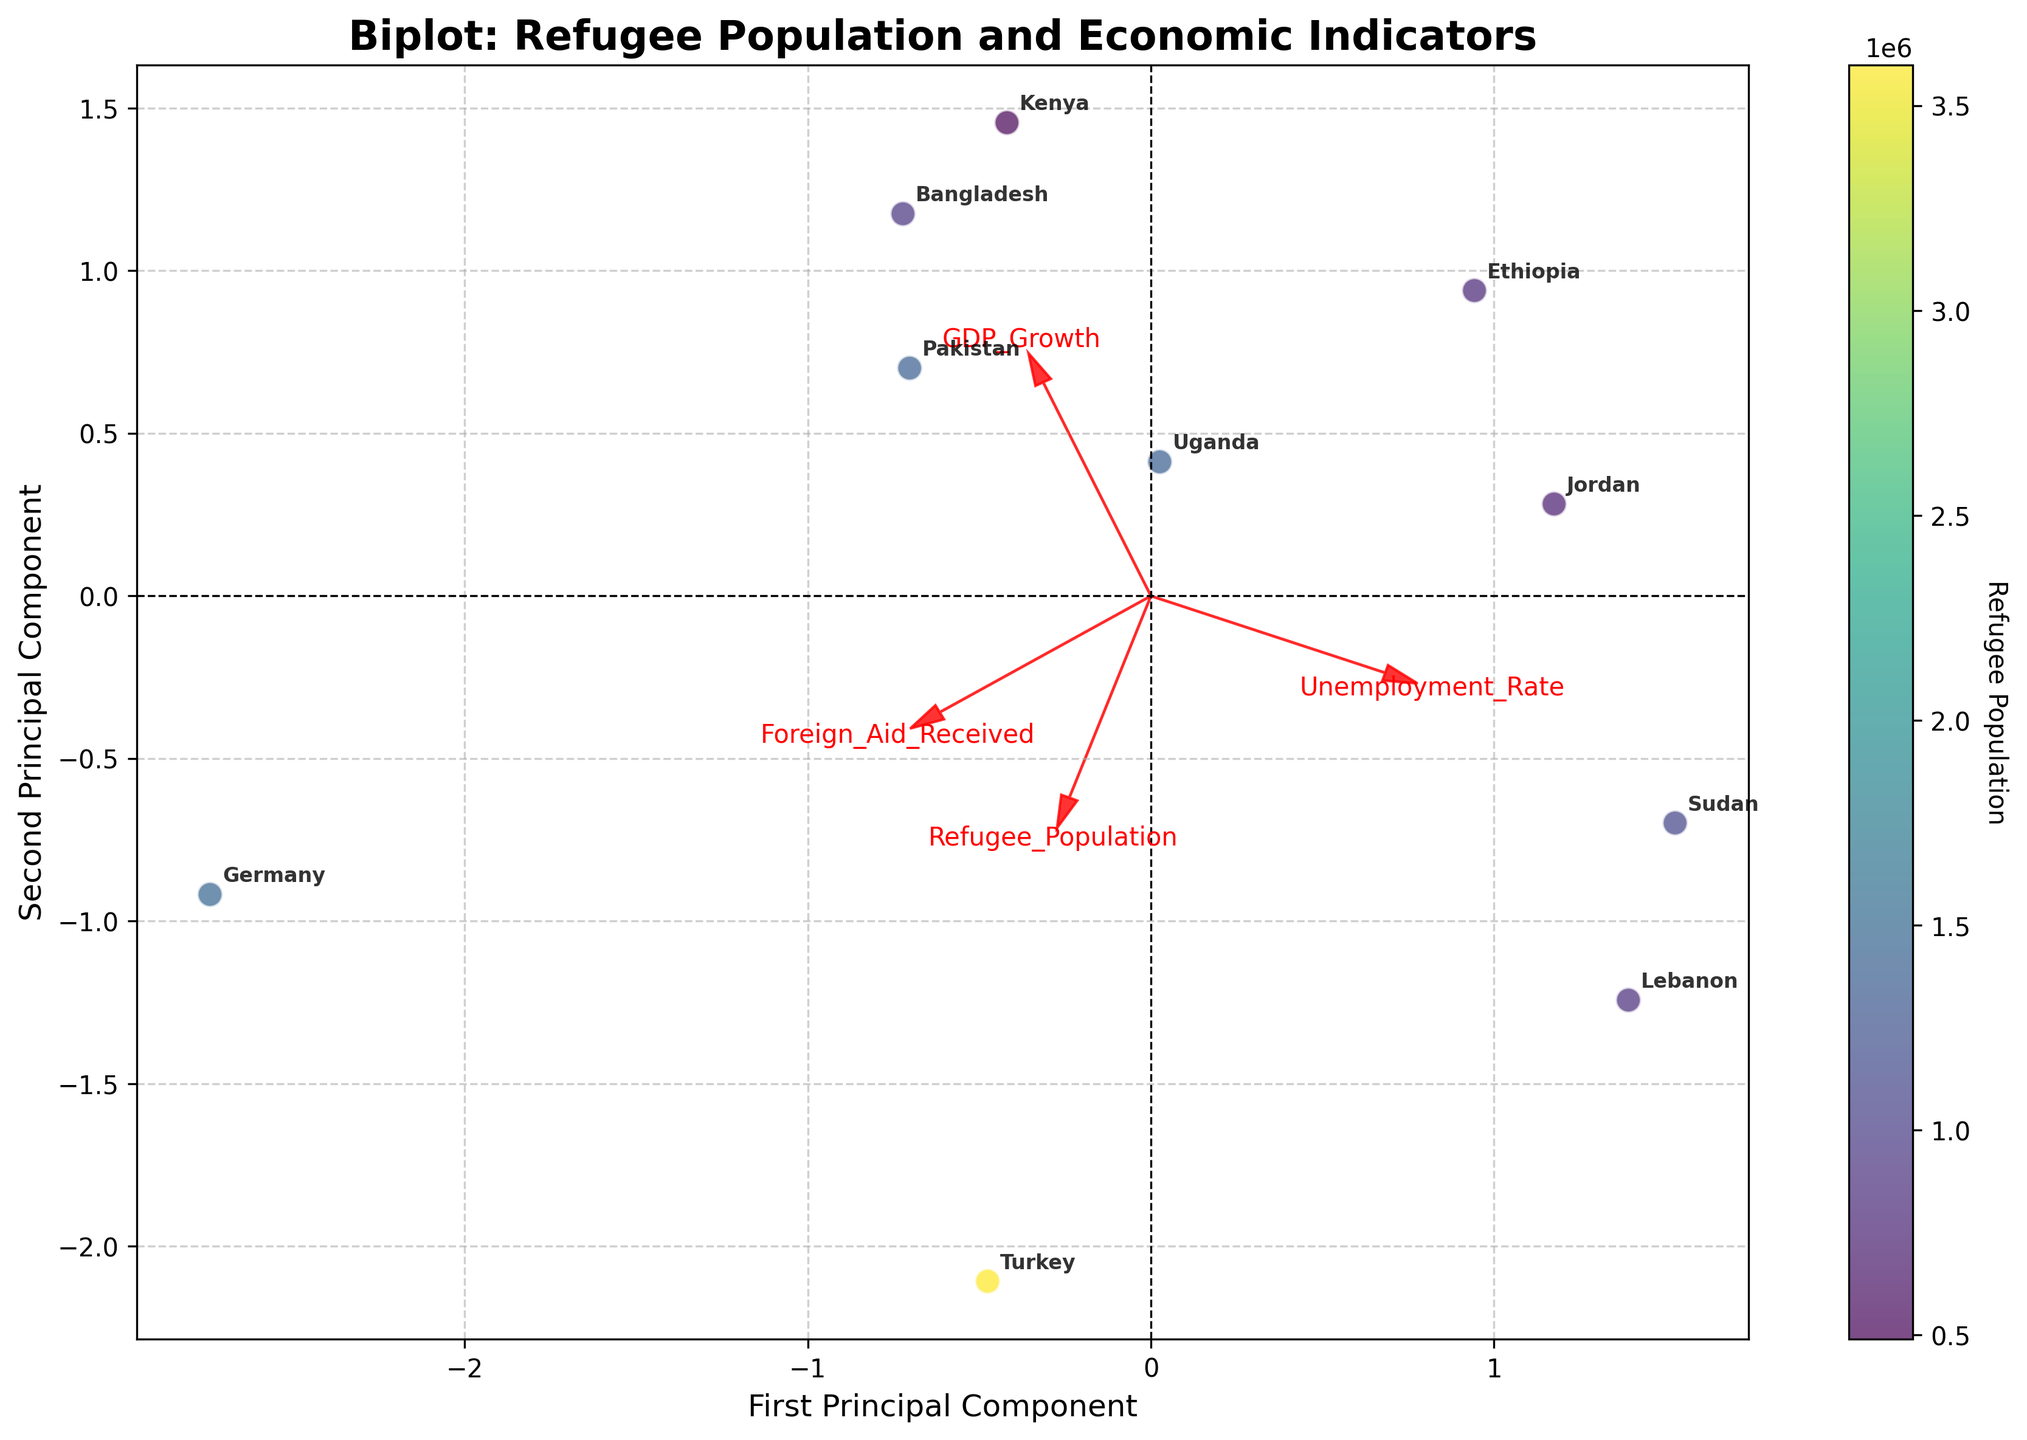Which country hosts the largest refugee population? The figure indicates the refugee population using the color gradient, and Germany and Turkey are the most prominent in this gradient. Upon closer inspection, Turkey is associated with the highest refugee population.
Answer: Turkey What are the features represented by the arrows? The figure includes arrows labeled as: Refugee_Population, GDP_Growth, Unemployment_Rate, and Foreign_Aid_Received. These represent the directional influence of each feature on the principal components.
Answer: Refugee_Population, GDP_Growth, Unemployment_Rate, Foreign_Aid_Received Which feature has the most significant influence on the first principal component? Observe the arrows and note which one aligns most closely with the horizontal axis. The Refugee_Population arrow is most aligned, indicating its prominence in the first principal component.
Answer: Refugee_Population How does Lebanon compare in terms of economic indicators and refugee population on the biplot? Lebanon has a negative GDP growth and high unemployment rate, placing it in the lower-left quadrant. It hosts a significant number of refugees but not the highest. The position near negative GDP Growth and higher Unemployment Rate arrows indicates its economic struggles.
Answer: Negative GDP Growth, High Unemployment Rate Which country is most aligned with high GDP growth? Examine the plot and follow the GDP_Growth arrow. Uganda is closest to this direction, highlighting its high GDP growth rate.
Answer: Uganda Are there any countries with both high Unemployment Rate and large Refugee Population? Review the positions relative to the Unemployment_Rate arrow and color gradient. Ethiopia and Lebanon exhibit these characteristics, being high on the Unemployment_Rate scale and significantly colored.
Answer: Ethiopia, Lebanon Which two features seem to have an inverse relationship in the biplot? Look at the angles between feature arrows. GDP_Growth and Unemployment_Rate arrows are nearly opposite each other, suggesting an inverse relationship.
Answer: GDP_Growth and Unemployment_Rate Where does Sudan fall on the principal components plot, and what does it imply about its economy and refugee situation? Sudan is placed in the lower quadrants with elements of both negative GDP growth and high unemployment. Its substantial refugee population colors it noticeably. This indicates significant economic hurdles and substantial foreign aid.
Answer: Lower quadrants, Negative GDP Growth, High Unemployment Rate How is the concept of "Foreign_Aid_Received" visually represented in the plot? The Foreign_Aid_Received arrow direction indicates that countries receiving substantial foreign aid align towards this vector, with Germany and Turkey relatively closer.
Answer: By an arrow pointing towards countries with significant foreign aid Which country hosts the fewest refugees, and what does their economic situation look like? Bangladesh is nearest to the lower end of the color gradient, suggesting the fewest refugees. Bangladesh's alignment with positive GDP growth and moderate unemployment implies a relatively stable economy.
Answer: Bangladesh, stable economy 